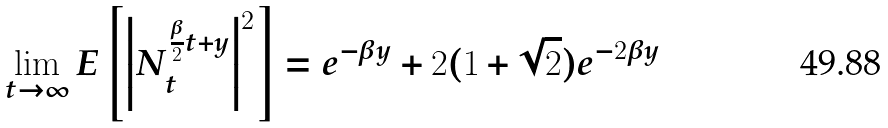Convert formula to latex. <formula><loc_0><loc_0><loc_500><loc_500>\lim _ { t \to \infty } E \left [ \left | N _ { t } ^ { \frac { \beta } { 2 } t + y } \right | ^ { 2 } \right ] = e ^ { - \beta y } + 2 ( 1 + \sqrt { 2 } ) e ^ { - 2 \beta y }</formula> 